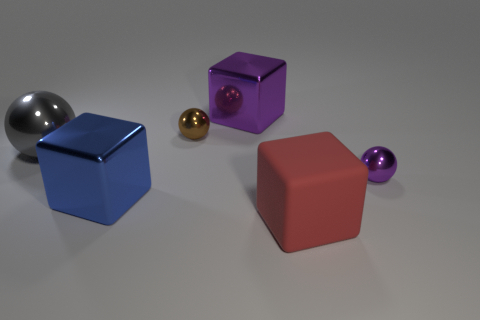Reflecting on the color palette of the image, could you describe the mood it conveys? The color palette, dominated by cool grays and deep blues, punctuated by warmer purple and red, evokes a calm, balanced, yet dynamic atmosphere, possibly suggesting modernity and minimalism. How might the lighting affect the perception of the materials? The soft and diffuse lighting accentuates the glossiness of the surfaces, highlighting the reflections and subtle shadows, which enhance the perception of the objects as three-dimensional and tangible. 